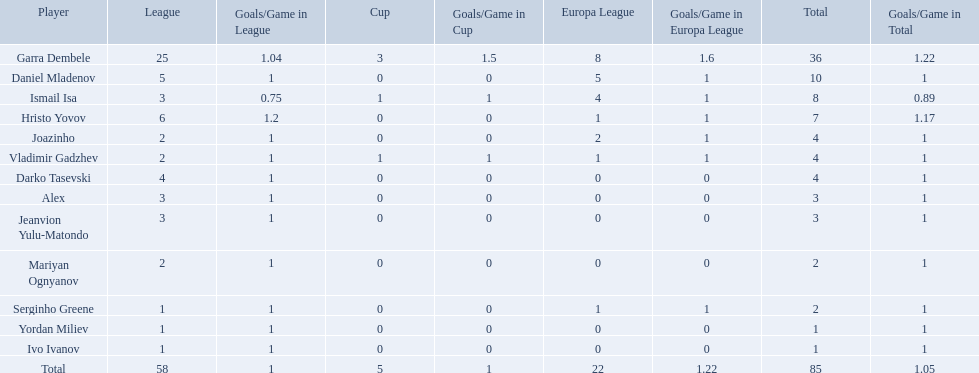What players did not score in all 3 competitions? Daniel Mladenov, Hristo Yovov, Joazinho, Darko Tasevski, Alex, Jeanvion Yulu-Matondo, Mariyan Ognyanov, Serginho Greene, Yordan Miliev, Ivo Ivanov. Which of those did not have total more then 5? Darko Tasevski, Alex, Jeanvion Yulu-Matondo, Mariyan Ognyanov, Serginho Greene, Yordan Miliev, Ivo Ivanov. Which ones scored more then 1 total? Darko Tasevski, Alex, Jeanvion Yulu-Matondo, Mariyan Ognyanov. Which of these player had the lease league points? Mariyan Ognyanov. 